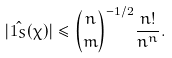Convert formula to latex. <formula><loc_0><loc_0><loc_500><loc_500>| \hat { 1 _ { S } } ( \chi ) | \leq \binom { n } { m } ^ { - 1 / 2 } \frac { n ! } { n ^ { n } } .</formula> 